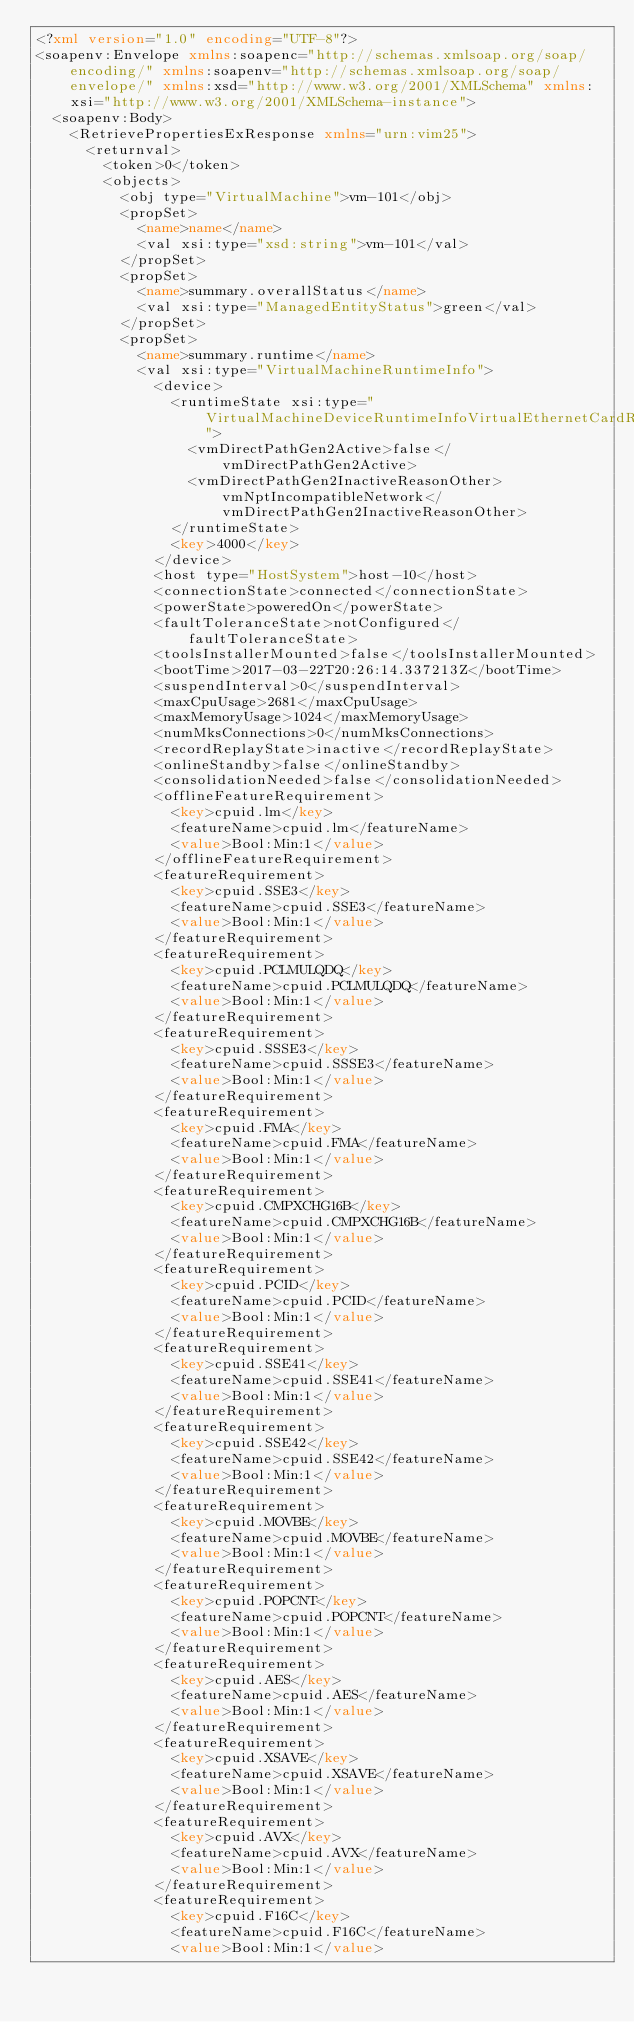<code> <loc_0><loc_0><loc_500><loc_500><_XML_><?xml version="1.0" encoding="UTF-8"?>
<soapenv:Envelope xmlns:soapenc="http://schemas.xmlsoap.org/soap/encoding/" xmlns:soapenv="http://schemas.xmlsoap.org/soap/envelope/" xmlns:xsd="http://www.w3.org/2001/XMLSchema" xmlns:xsi="http://www.w3.org/2001/XMLSchema-instance">
  <soapenv:Body>
    <RetrievePropertiesExResponse xmlns="urn:vim25">
      <returnval>
        <token>0</token>
        <objects>
          <obj type="VirtualMachine">vm-101</obj>
          <propSet>
            <name>name</name>
            <val xsi:type="xsd:string">vm-101</val>
          </propSet>
          <propSet>
            <name>summary.overallStatus</name>
            <val xsi:type="ManagedEntityStatus">green</val>
          </propSet>
          <propSet>
            <name>summary.runtime</name>
            <val xsi:type="VirtualMachineRuntimeInfo">
              <device>
                <runtimeState xsi:type="VirtualMachineDeviceRuntimeInfoVirtualEthernetCardRuntimeState">
                  <vmDirectPathGen2Active>false</vmDirectPathGen2Active>
                  <vmDirectPathGen2InactiveReasonOther>vmNptIncompatibleNetwork</vmDirectPathGen2InactiveReasonOther>
                </runtimeState>
                <key>4000</key>
              </device>
              <host type="HostSystem">host-10</host>
              <connectionState>connected</connectionState>
              <powerState>poweredOn</powerState>
              <faultToleranceState>notConfigured</faultToleranceState>
              <toolsInstallerMounted>false</toolsInstallerMounted>
              <bootTime>2017-03-22T20:26:14.337213Z</bootTime>
              <suspendInterval>0</suspendInterval>
              <maxCpuUsage>2681</maxCpuUsage>
              <maxMemoryUsage>1024</maxMemoryUsage>
              <numMksConnections>0</numMksConnections>
              <recordReplayState>inactive</recordReplayState>
              <onlineStandby>false</onlineStandby>
              <consolidationNeeded>false</consolidationNeeded>
              <offlineFeatureRequirement>
                <key>cpuid.lm</key>
                <featureName>cpuid.lm</featureName>
                <value>Bool:Min:1</value>
              </offlineFeatureRequirement>
              <featureRequirement>
                <key>cpuid.SSE3</key>
                <featureName>cpuid.SSE3</featureName>
                <value>Bool:Min:1</value>
              </featureRequirement>
              <featureRequirement>
                <key>cpuid.PCLMULQDQ</key>
                <featureName>cpuid.PCLMULQDQ</featureName>
                <value>Bool:Min:1</value>
              </featureRequirement>
              <featureRequirement>
                <key>cpuid.SSSE3</key>
                <featureName>cpuid.SSSE3</featureName>
                <value>Bool:Min:1</value>
              </featureRequirement>
              <featureRequirement>
                <key>cpuid.FMA</key>
                <featureName>cpuid.FMA</featureName>
                <value>Bool:Min:1</value>
              </featureRequirement>
              <featureRequirement>
                <key>cpuid.CMPXCHG16B</key>
                <featureName>cpuid.CMPXCHG16B</featureName>
                <value>Bool:Min:1</value>
              </featureRequirement>
              <featureRequirement>
                <key>cpuid.PCID</key>
                <featureName>cpuid.PCID</featureName>
                <value>Bool:Min:1</value>
              </featureRequirement>
              <featureRequirement>
                <key>cpuid.SSE41</key>
                <featureName>cpuid.SSE41</featureName>
                <value>Bool:Min:1</value>
              </featureRequirement>
              <featureRequirement>
                <key>cpuid.SSE42</key>
                <featureName>cpuid.SSE42</featureName>
                <value>Bool:Min:1</value>
              </featureRequirement>
              <featureRequirement>
                <key>cpuid.MOVBE</key>
                <featureName>cpuid.MOVBE</featureName>
                <value>Bool:Min:1</value>
              </featureRequirement>
              <featureRequirement>
                <key>cpuid.POPCNT</key>
                <featureName>cpuid.POPCNT</featureName>
                <value>Bool:Min:1</value>
              </featureRequirement>
              <featureRequirement>
                <key>cpuid.AES</key>
                <featureName>cpuid.AES</featureName>
                <value>Bool:Min:1</value>
              </featureRequirement>
              <featureRequirement>
                <key>cpuid.XSAVE</key>
                <featureName>cpuid.XSAVE</featureName>
                <value>Bool:Min:1</value>
              </featureRequirement>
              <featureRequirement>
                <key>cpuid.AVX</key>
                <featureName>cpuid.AVX</featureName>
                <value>Bool:Min:1</value>
              </featureRequirement>
              <featureRequirement>
                <key>cpuid.F16C</key>
                <featureName>cpuid.F16C</featureName>
                <value>Bool:Min:1</value></code> 